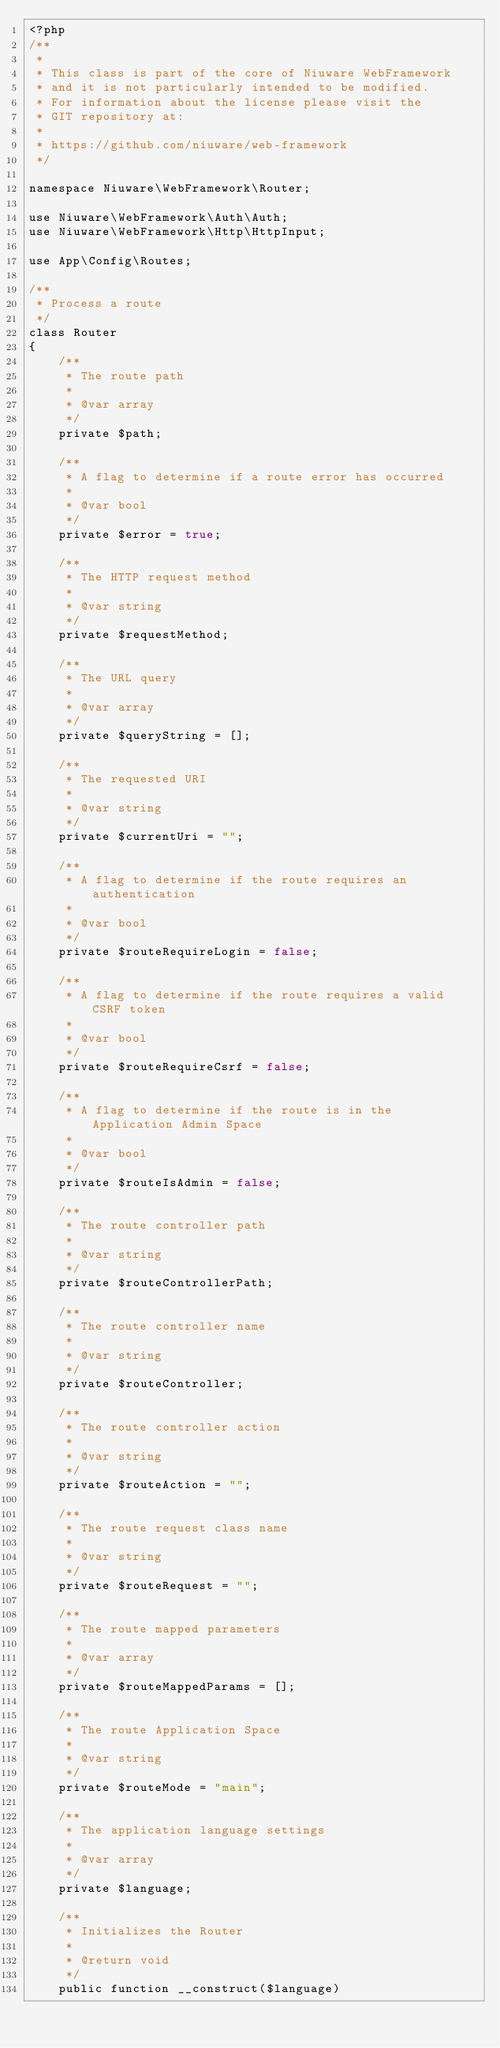Convert code to text. <code><loc_0><loc_0><loc_500><loc_500><_PHP_><?php 
/**
 * 
 * This class is part of the core of Niuware WebFramework 
 * and it is not particularly intended to be modified.
 * For information about the license please visit the 
 * GIT repository at:
 * 
 * https://github.com/niuware/web-framework
 */

namespace Niuware\WebFramework\Router;

use Niuware\WebFramework\Auth\Auth;
use Niuware\WebFramework\Http\HttpInput;

use App\Config\Routes;

/**
 * Process a route
 */
class Router
{
    /**
     * The route path
     * 
     * @var array 
     */
    private $path;

    /**
     * A flag to determine if a route error has occurred
     * 
     * @var bool 
     */
    private $error = true;
    
    /**
     * The HTTP request method
     * 
     * @var string 
     */
    private $requestMethod;
    
    /**
     * The URL query
     * 
     * @var array 
     */
    private $queryString = [];
    
    /**
     * The requested URI
     * 
     * @var string 
     */
    private $currentUri = "";
    
    /**
     * A flag to determine if the route requires an authentication
     * 
     * @var bool 
     */
    private $routeRequireLogin = false;
    
    /**
     * A flag to determine if the route requires a valid CSRF token
     * 
     * @var bool 
     */
    private $routeRequireCsrf = false;
    
    /**
     * A flag to determine if the route is in the Application Admin Space
     * 
     * @var bool 
     */
    private $routeIsAdmin = false;
    
    /**
     * The route controller path
     * 
     * @var string 
     */
    private $routeControllerPath;
    
    /**
     * The route controller name
     * 
     * @var string 
     */
    private $routeController;
    
    /**
     * The route controller action
     * 
     * @var string 
     */
    private $routeAction = "";
    
    /**
     * The route request class name
     * 
     * @var string 
     */
    private $routeRequest = "";
    
    /**
     * The route mapped parameters
     * 
     * @var array 
     */
    private $routeMappedParams = [];
    
    /**
     * The route Application Space
     * 
     * @var string 
     */
    private $routeMode = "main";
    
    /**
     * The application language settings
     * 
     * @var array 
     */
    private $language;

    /**
     * Initializes the Router
     * 
     * @return void
     */
    public function __construct($language)</code> 